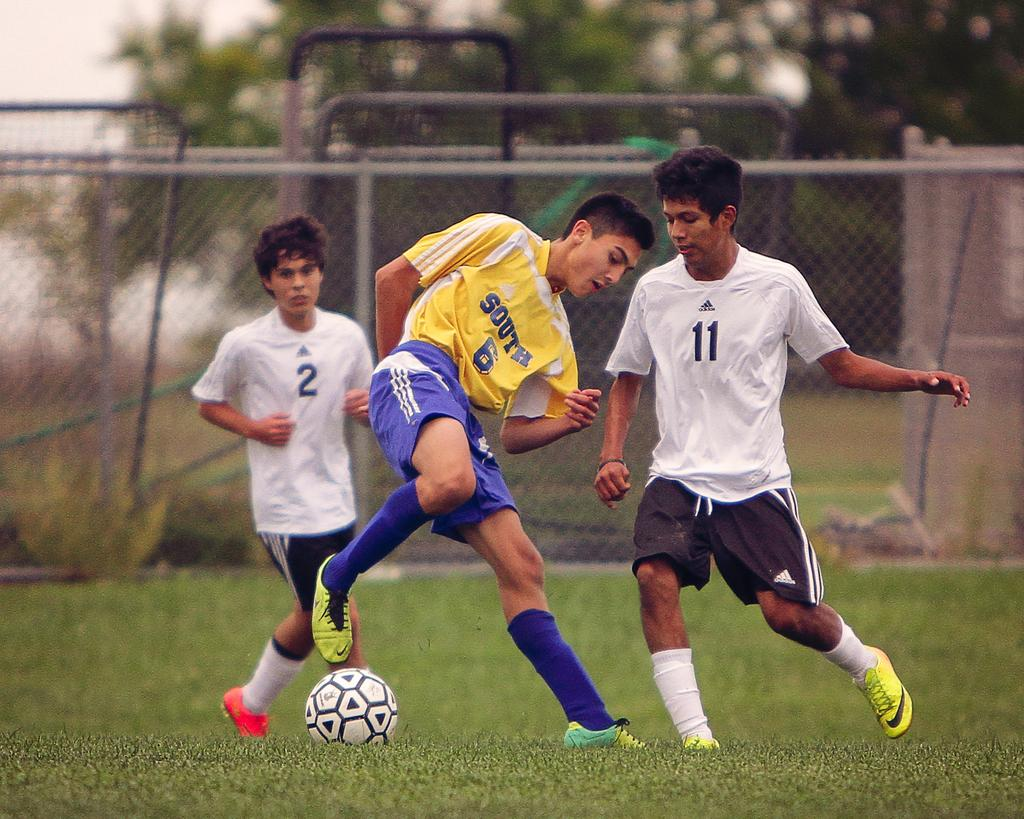What are the two people in the image doing? The two people in the image are running. Can you describe the person who is in motion in the image? There is a person in motion in the image, and they are running. What object is on the grass in the image? There is a ball on the grass in the image. What can be seen in the background of the image? In the background of the image, there is a fence, trees, and the sky. What type of flock can be seen flying in the image? There is no flock visible in the image; it features two people running and a ball on the grass. What discovery was made by the person in the image? There is no mention of a discovery in the image; it simply shows two people running and a ball on the grass. 